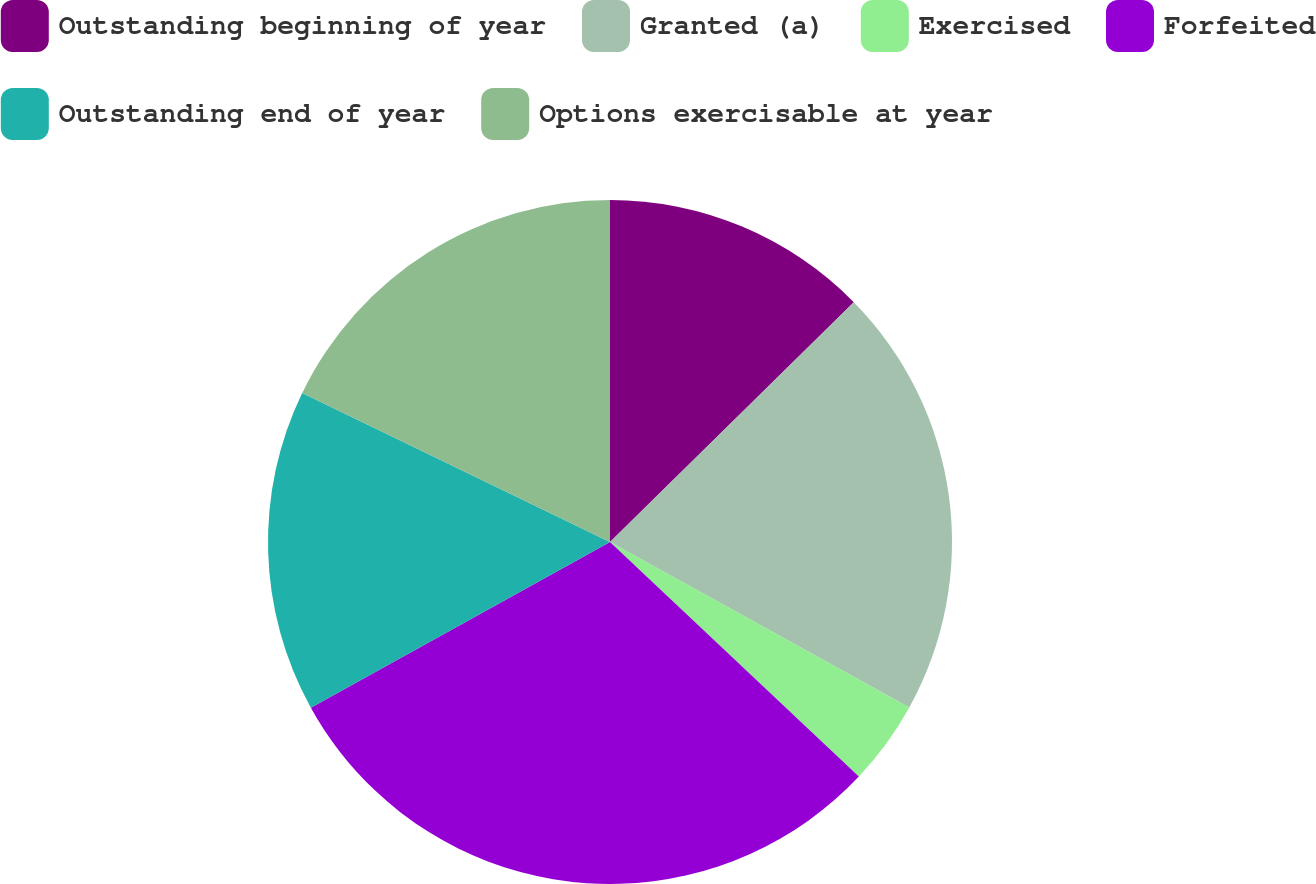Convert chart. <chart><loc_0><loc_0><loc_500><loc_500><pie_chart><fcel>Outstanding beginning of year<fcel>Granted (a)<fcel>Exercised<fcel>Forfeited<fcel>Outstanding end of year<fcel>Options exercisable at year<nl><fcel>12.63%<fcel>20.41%<fcel>3.99%<fcel>29.92%<fcel>15.23%<fcel>17.82%<nl></chart> 